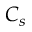<formula> <loc_0><loc_0><loc_500><loc_500>C _ { s }</formula> 